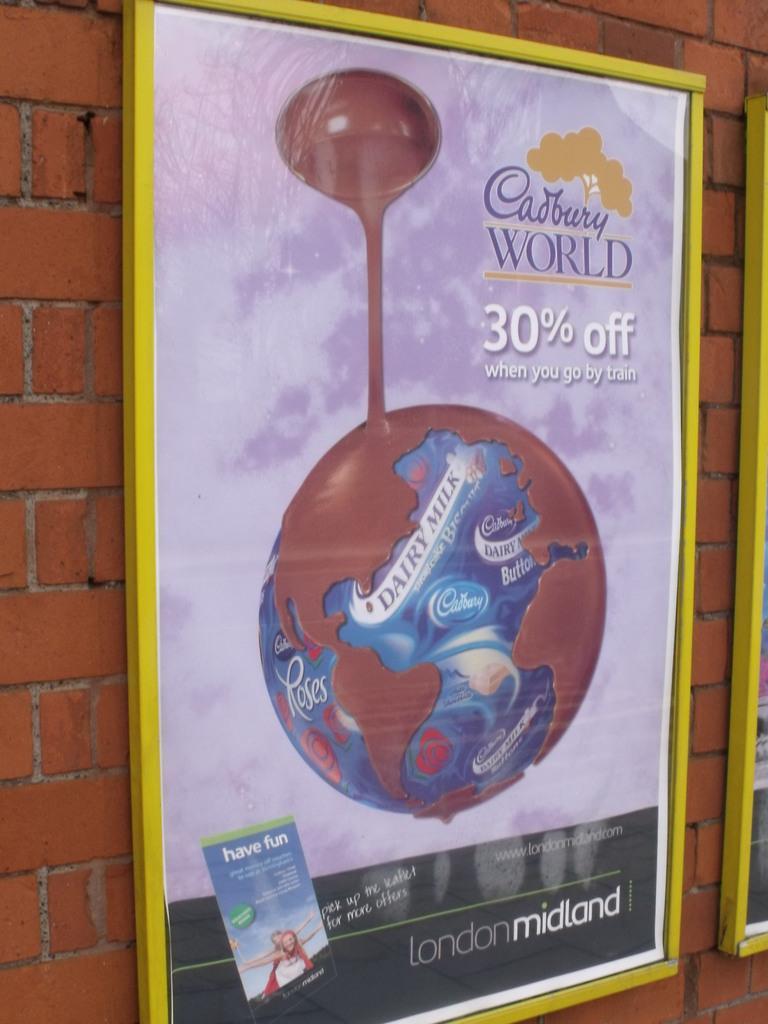In one or two sentences, can you explain what this image depicts? In the picture we can see a brick wall on it we can see a board with a advertisement of cadbury. 